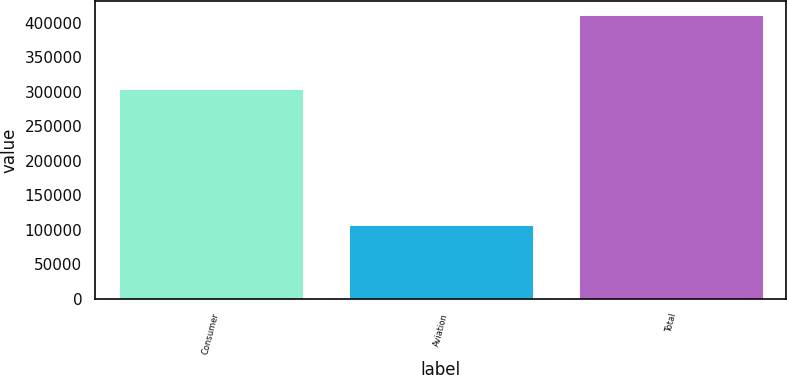Convert chart. <chart><loc_0><loc_0><loc_500><loc_500><bar_chart><fcel>Consumer<fcel>Aviation<fcel>Total<nl><fcel>304217<fcel>107022<fcel>411239<nl></chart> 